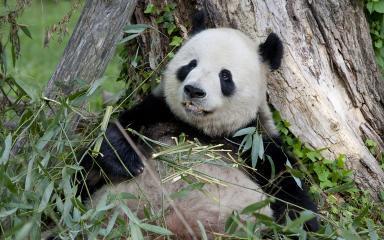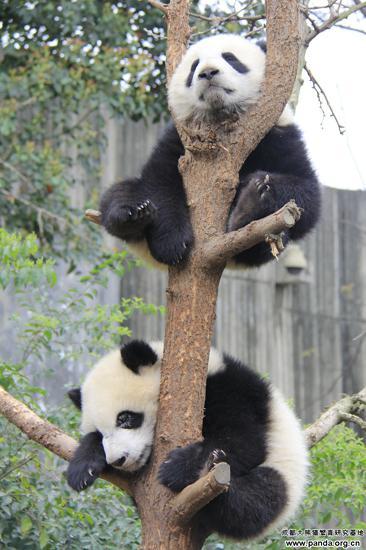The first image is the image on the left, the second image is the image on the right. Considering the images on both sides, is "A total of two pandas are off the ground and hanging to tree limbs." valid? Answer yes or no. Yes. 